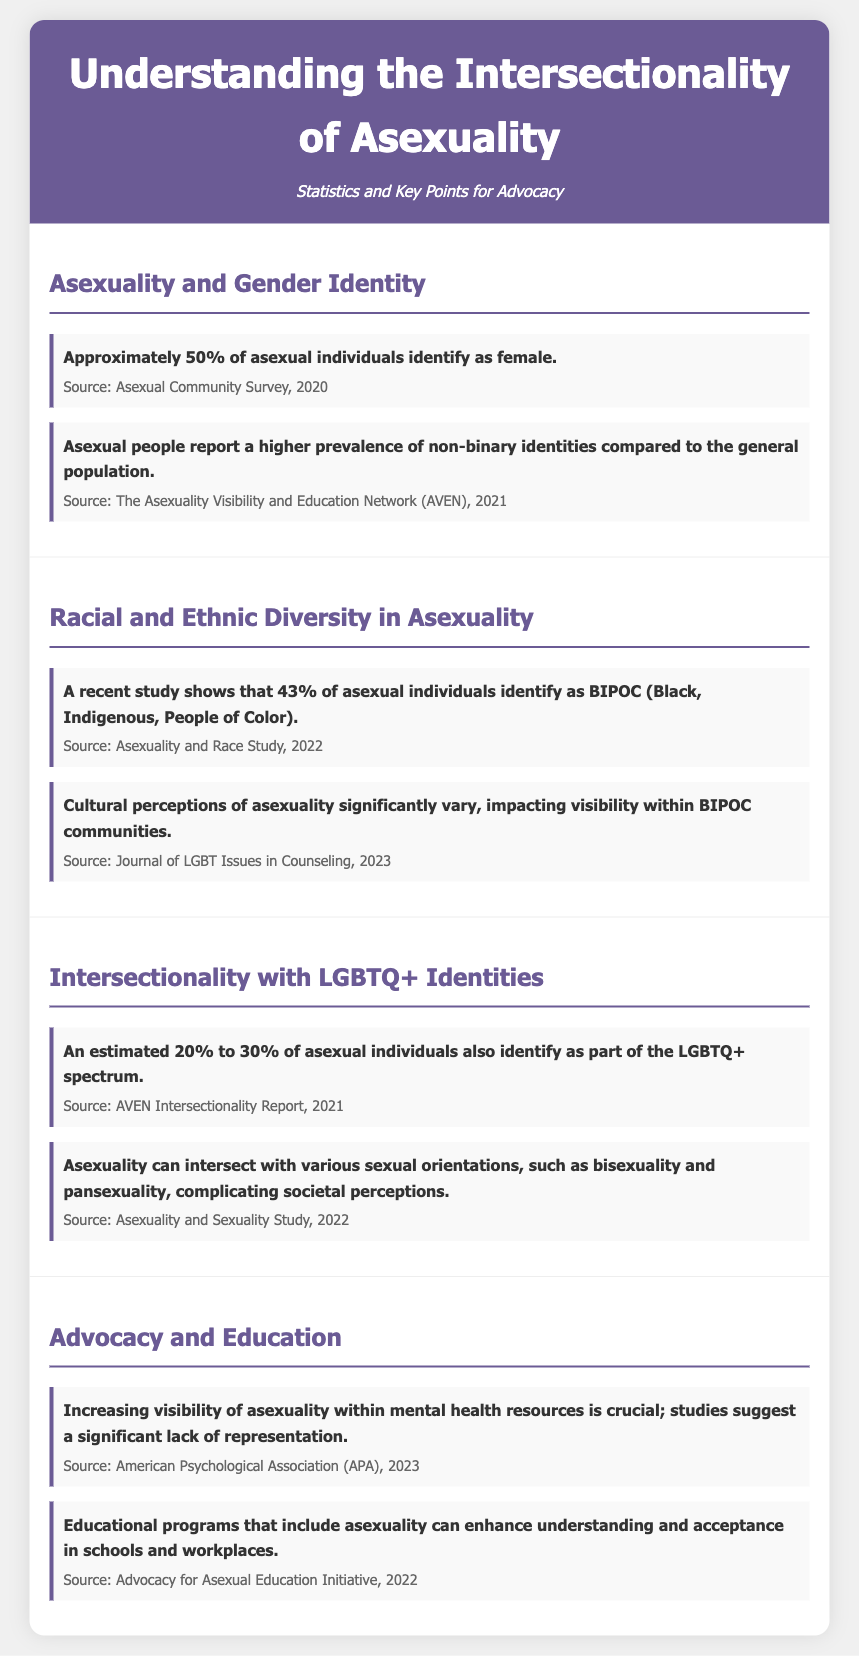what percentage of asexual individuals identify as female? The document states that approximately 50% of asexual individuals identify as female.
Answer: 50% what fraction of asexual individuals identify as BIPOC? The document reports that 43% of asexual individuals identify as BIPOC.
Answer: 43% what percentage of asexual individuals identify as part of the LGBTQ+ spectrum? The document mentions that an estimated 20% to 30% of asexual individuals identify as part of the LGBTQ+ spectrum.
Answer: 20% to 30% what is crucial for mental health resources regarding asexuality? The document highlights that increasing visibility of asexuality within mental health resources is crucial.
Answer: visibility which cultural factors impact visibility within BIPOC communities? The document states that cultural perceptions of asexuality significantly vary, impacting visibility within BIPOC communities.
Answer: cultural perceptions what type of educational programs can enhance understanding of asexuality? The document indicates that educational programs that include asexuality can enhance understanding and acceptance in schools and workplaces.
Answer: educational programs what organization conducted the survey regarding asexual individuals' gender identity? The document cites the Asexual Community Survey, 2020 as the source for gender identity statistics.
Answer: Asexual Community Survey which study discusses the intersectionality of asexuality and sexuality? The document references the Asexuality and Sexuality Study, 2022 for information on intersectionality with sexual orientations.
Answer: Asexuality and Sexuality Study what is a significant finding about non-binary identities among asexual individuals? The document states that asexual people report a higher prevalence of non-binary identities compared to the general population.
Answer: higher prevalence 